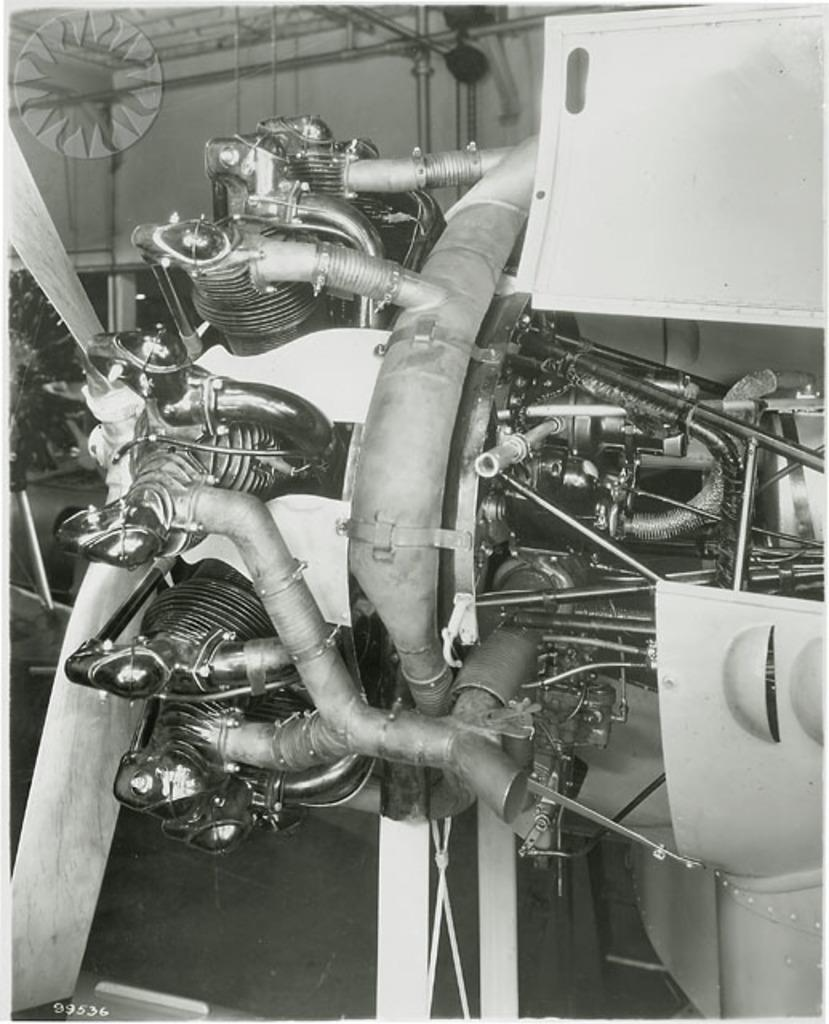What can be seen in the image? There is an object in the image. What is behind the object in the image? There is a wall behind the object. What is visible at the top of the image? There is a roof visible at the top of the image. What type of machine can be seen operating in the mine in the image? There is no machine or mine present in the image; it only features an object, a wall, and a roof. 